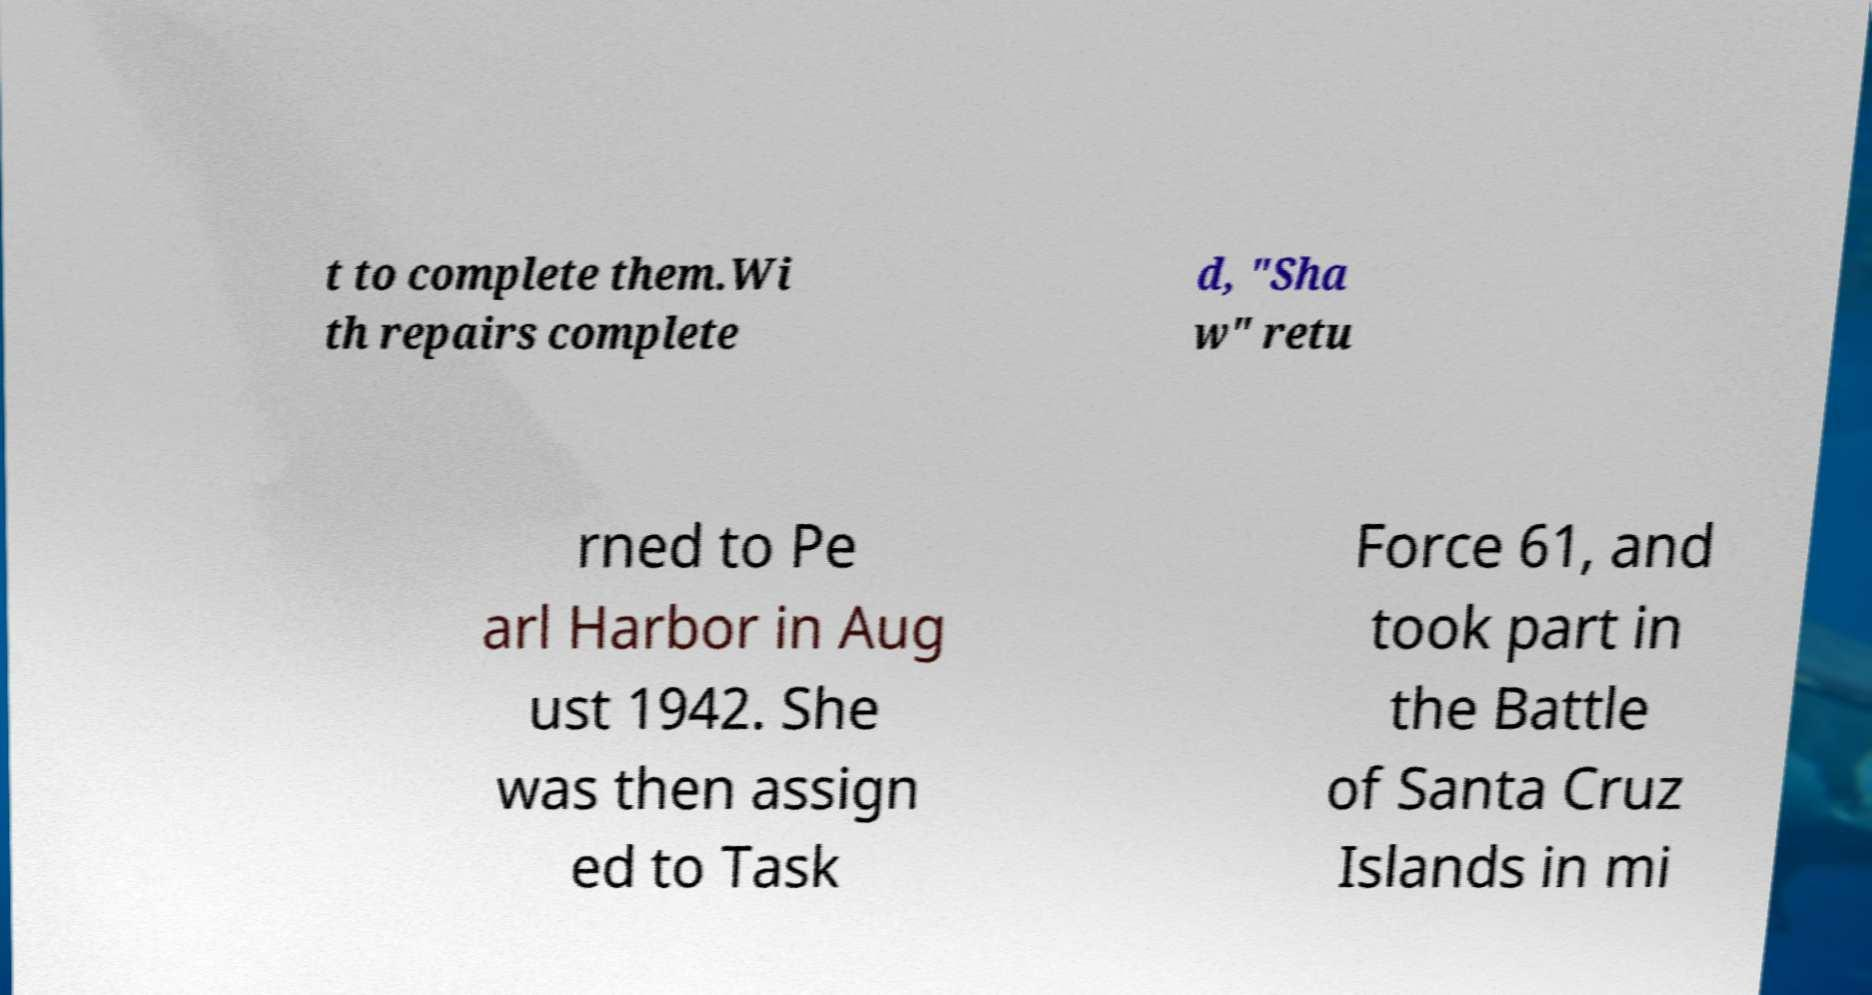What messages or text are displayed in this image? I need them in a readable, typed format. t to complete them.Wi th repairs complete d, "Sha w" retu rned to Pe arl Harbor in Aug ust 1942. She was then assign ed to Task Force 61, and took part in the Battle of Santa Cruz Islands in mi 